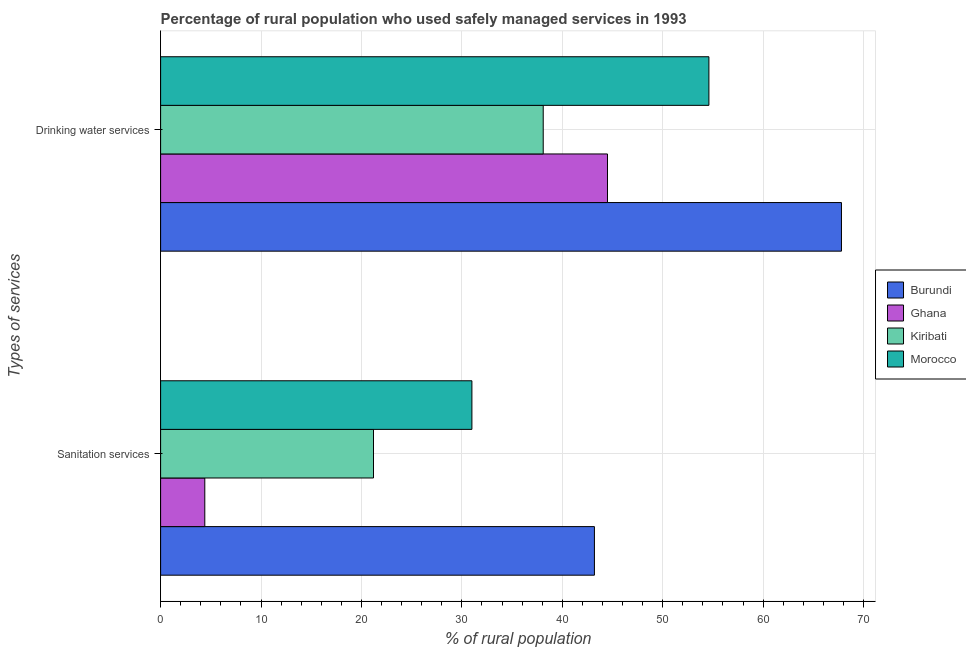How many different coloured bars are there?
Offer a terse response. 4. Are the number of bars per tick equal to the number of legend labels?
Provide a succinct answer. Yes. Are the number of bars on each tick of the Y-axis equal?
Your answer should be very brief. Yes. How many bars are there on the 2nd tick from the top?
Provide a short and direct response. 4. How many bars are there on the 1st tick from the bottom?
Your answer should be compact. 4. What is the label of the 2nd group of bars from the top?
Make the answer very short. Sanitation services. What is the percentage of rural population who used sanitation services in Kiribati?
Provide a succinct answer. 21.2. Across all countries, what is the maximum percentage of rural population who used sanitation services?
Give a very brief answer. 43.2. Across all countries, what is the minimum percentage of rural population who used drinking water services?
Offer a very short reply. 38.1. In which country was the percentage of rural population who used sanitation services maximum?
Provide a short and direct response. Burundi. What is the total percentage of rural population who used drinking water services in the graph?
Your answer should be very brief. 205. What is the difference between the percentage of rural population who used sanitation services in Ghana and that in Morocco?
Your answer should be very brief. -26.6. What is the difference between the percentage of rural population who used drinking water services in Ghana and the percentage of rural population who used sanitation services in Morocco?
Ensure brevity in your answer.  13.5. What is the average percentage of rural population who used drinking water services per country?
Your response must be concise. 51.25. What is the difference between the percentage of rural population who used sanitation services and percentage of rural population who used drinking water services in Ghana?
Your answer should be compact. -40.1. In how many countries, is the percentage of rural population who used sanitation services greater than 40 %?
Give a very brief answer. 1. What is the ratio of the percentage of rural population who used drinking water services in Kiribati to that in Burundi?
Your answer should be very brief. 0.56. What does the 4th bar from the top in Sanitation services represents?
Provide a succinct answer. Burundi. How many bars are there?
Ensure brevity in your answer.  8. Are all the bars in the graph horizontal?
Offer a very short reply. Yes. How many countries are there in the graph?
Ensure brevity in your answer.  4. Are the values on the major ticks of X-axis written in scientific E-notation?
Ensure brevity in your answer.  No. Where does the legend appear in the graph?
Offer a terse response. Center right. How many legend labels are there?
Your answer should be compact. 4. How are the legend labels stacked?
Provide a succinct answer. Vertical. What is the title of the graph?
Your response must be concise. Percentage of rural population who used safely managed services in 1993. What is the label or title of the X-axis?
Your answer should be compact. % of rural population. What is the label or title of the Y-axis?
Make the answer very short. Types of services. What is the % of rural population of Burundi in Sanitation services?
Give a very brief answer. 43.2. What is the % of rural population of Ghana in Sanitation services?
Your answer should be very brief. 4.4. What is the % of rural population of Kiribati in Sanitation services?
Offer a very short reply. 21.2. What is the % of rural population of Morocco in Sanitation services?
Provide a short and direct response. 31. What is the % of rural population of Burundi in Drinking water services?
Ensure brevity in your answer.  67.8. What is the % of rural population of Ghana in Drinking water services?
Keep it short and to the point. 44.5. What is the % of rural population of Kiribati in Drinking water services?
Ensure brevity in your answer.  38.1. What is the % of rural population of Morocco in Drinking water services?
Offer a terse response. 54.6. Across all Types of services, what is the maximum % of rural population of Burundi?
Your response must be concise. 67.8. Across all Types of services, what is the maximum % of rural population of Ghana?
Your answer should be compact. 44.5. Across all Types of services, what is the maximum % of rural population in Kiribati?
Keep it short and to the point. 38.1. Across all Types of services, what is the maximum % of rural population in Morocco?
Your response must be concise. 54.6. Across all Types of services, what is the minimum % of rural population of Burundi?
Your response must be concise. 43.2. Across all Types of services, what is the minimum % of rural population in Ghana?
Make the answer very short. 4.4. Across all Types of services, what is the minimum % of rural population in Kiribati?
Provide a short and direct response. 21.2. Across all Types of services, what is the minimum % of rural population in Morocco?
Keep it short and to the point. 31. What is the total % of rural population of Burundi in the graph?
Keep it short and to the point. 111. What is the total % of rural population of Ghana in the graph?
Give a very brief answer. 48.9. What is the total % of rural population of Kiribati in the graph?
Provide a succinct answer. 59.3. What is the total % of rural population in Morocco in the graph?
Offer a terse response. 85.6. What is the difference between the % of rural population of Burundi in Sanitation services and that in Drinking water services?
Provide a succinct answer. -24.6. What is the difference between the % of rural population in Ghana in Sanitation services and that in Drinking water services?
Provide a short and direct response. -40.1. What is the difference between the % of rural population in Kiribati in Sanitation services and that in Drinking water services?
Your answer should be very brief. -16.9. What is the difference between the % of rural population of Morocco in Sanitation services and that in Drinking water services?
Ensure brevity in your answer.  -23.6. What is the difference between the % of rural population in Burundi in Sanitation services and the % of rural population in Morocco in Drinking water services?
Your answer should be very brief. -11.4. What is the difference between the % of rural population in Ghana in Sanitation services and the % of rural population in Kiribati in Drinking water services?
Make the answer very short. -33.7. What is the difference between the % of rural population in Ghana in Sanitation services and the % of rural population in Morocco in Drinking water services?
Ensure brevity in your answer.  -50.2. What is the difference between the % of rural population of Kiribati in Sanitation services and the % of rural population of Morocco in Drinking water services?
Offer a very short reply. -33.4. What is the average % of rural population in Burundi per Types of services?
Offer a terse response. 55.5. What is the average % of rural population in Ghana per Types of services?
Your answer should be compact. 24.45. What is the average % of rural population in Kiribati per Types of services?
Offer a very short reply. 29.65. What is the average % of rural population of Morocco per Types of services?
Your answer should be very brief. 42.8. What is the difference between the % of rural population of Burundi and % of rural population of Ghana in Sanitation services?
Provide a succinct answer. 38.8. What is the difference between the % of rural population in Burundi and % of rural population in Kiribati in Sanitation services?
Provide a short and direct response. 22. What is the difference between the % of rural population of Ghana and % of rural population of Kiribati in Sanitation services?
Provide a succinct answer. -16.8. What is the difference between the % of rural population of Ghana and % of rural population of Morocco in Sanitation services?
Your answer should be compact. -26.6. What is the difference between the % of rural population of Burundi and % of rural population of Ghana in Drinking water services?
Offer a very short reply. 23.3. What is the difference between the % of rural population in Burundi and % of rural population in Kiribati in Drinking water services?
Ensure brevity in your answer.  29.7. What is the difference between the % of rural population of Ghana and % of rural population of Morocco in Drinking water services?
Offer a very short reply. -10.1. What is the difference between the % of rural population in Kiribati and % of rural population in Morocco in Drinking water services?
Provide a succinct answer. -16.5. What is the ratio of the % of rural population of Burundi in Sanitation services to that in Drinking water services?
Keep it short and to the point. 0.64. What is the ratio of the % of rural population of Ghana in Sanitation services to that in Drinking water services?
Your answer should be compact. 0.1. What is the ratio of the % of rural population in Kiribati in Sanitation services to that in Drinking water services?
Make the answer very short. 0.56. What is the ratio of the % of rural population of Morocco in Sanitation services to that in Drinking water services?
Keep it short and to the point. 0.57. What is the difference between the highest and the second highest % of rural population of Burundi?
Your answer should be compact. 24.6. What is the difference between the highest and the second highest % of rural population in Ghana?
Give a very brief answer. 40.1. What is the difference between the highest and the second highest % of rural population of Kiribati?
Provide a succinct answer. 16.9. What is the difference between the highest and the second highest % of rural population in Morocco?
Make the answer very short. 23.6. What is the difference between the highest and the lowest % of rural population of Burundi?
Provide a succinct answer. 24.6. What is the difference between the highest and the lowest % of rural population of Ghana?
Offer a very short reply. 40.1. What is the difference between the highest and the lowest % of rural population in Morocco?
Give a very brief answer. 23.6. 